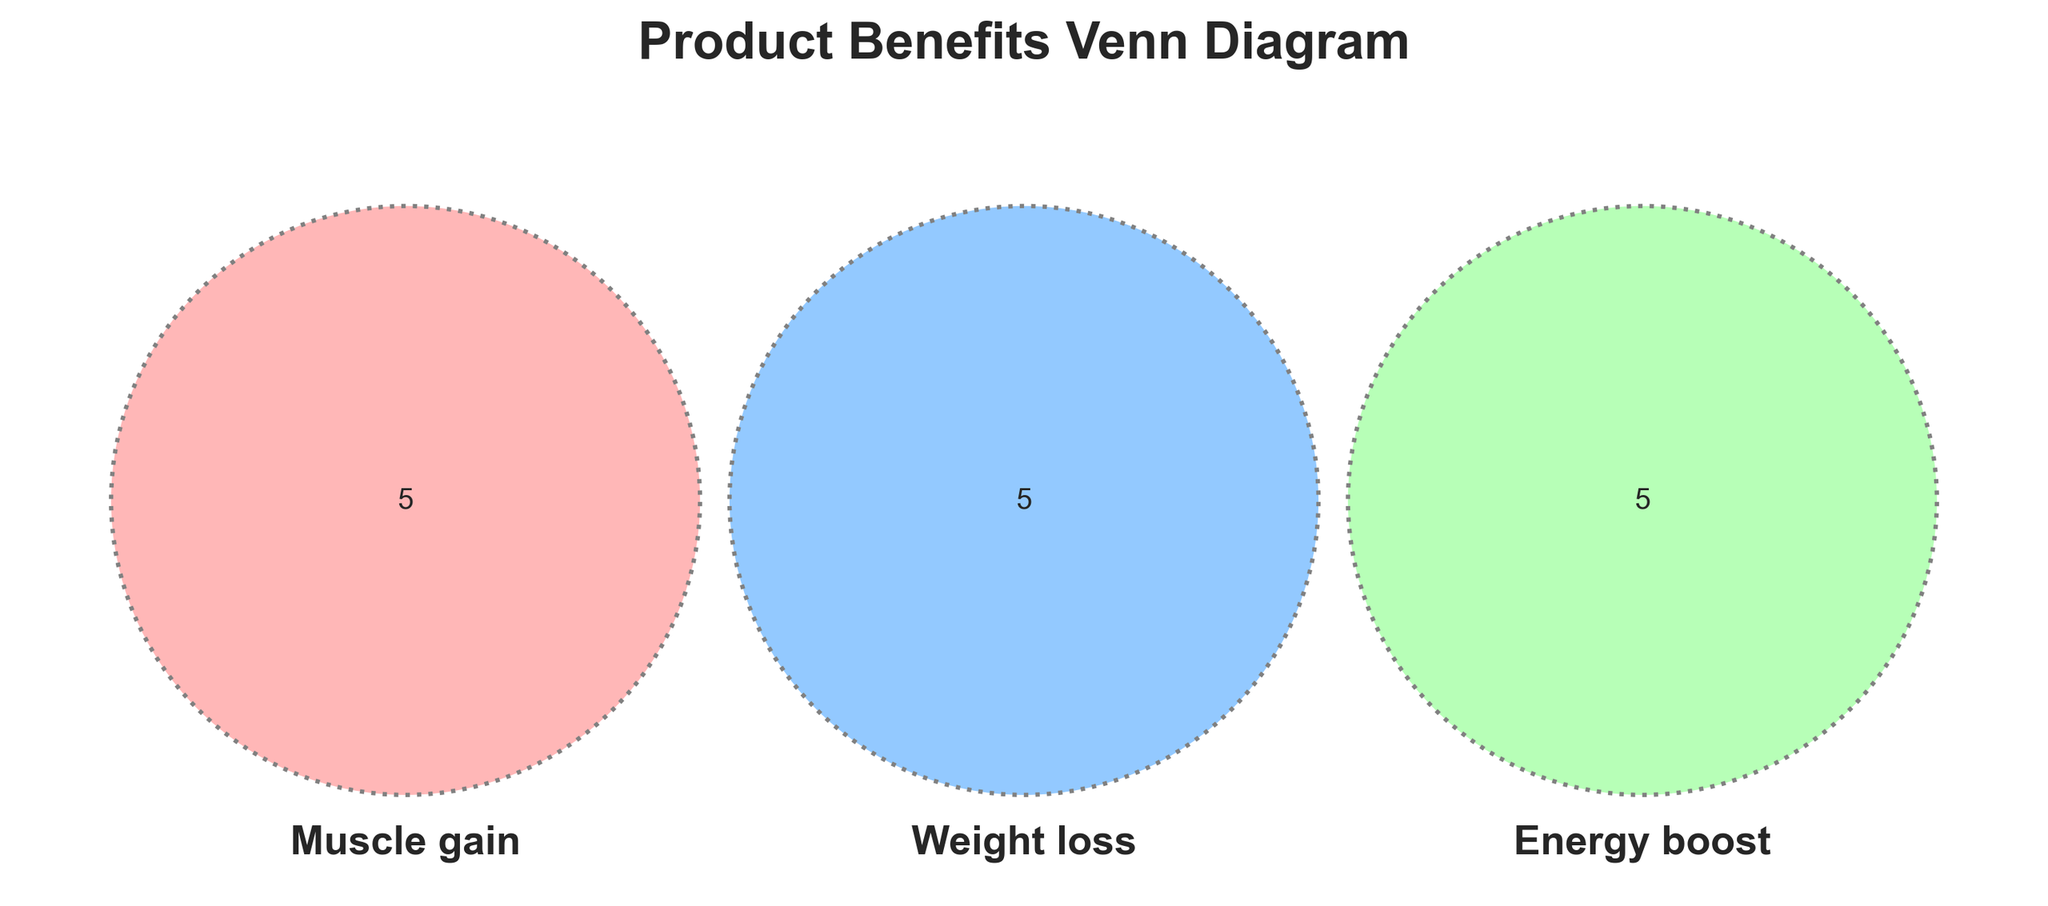What are the three main benefits illustrated in the Venn Diagram? The Venn Diagram illustrates three main benefits, which are labeled with the set names: Muscle gain, Weight loss, and Energy boost.
Answer: Muscle gain, Weight loss, Energy boost Which specific component is unique to Weight loss? The segments of the Venn Diagram label elements specific to each benefit. The section exclusive to Weight loss includes one of the labels, specifically Fiber.
Answer: Fiber How many components are listed under Muscle gain? The Venn Diagram has several labeled sections. The segment for Muscle gain includes six elements: Whey protein, Creatine, Amino acids, Strength training, High protein, and one more.
Answer: Six Is Green tea extract shared by Muscle gain and Energy boost? By examining the overlap areas in the Venn Diagram, we find that Green tea extract appears only in the Weight loss segment and does not overlap with Muscle gain or Energy boost.
Answer: No Which benefit includes components like Portion control and Metabolism boost? Both Portion control and Metabolism boost fall under the Weight loss category, as indicated in the labeled Venn Diagram.
Answer: Weight loss Out of the identified benefits, which one has a component that boosts metabolism? In the Venn Diagram, the Metabolism boost entity can be found within the Weight loss section.
Answer: Weight loss Do any components appear across all three benefits? The segment at the very center of the Venn Diagram would show any shared components. In this diagram, no element falls within the intersection of all three benefits.
Answer: No How does the High protein component relate to the benefits? The High protein component appears only within the Muscle gain section and does not intersect with Weight loss or Energy boost.
Answer: Separate 